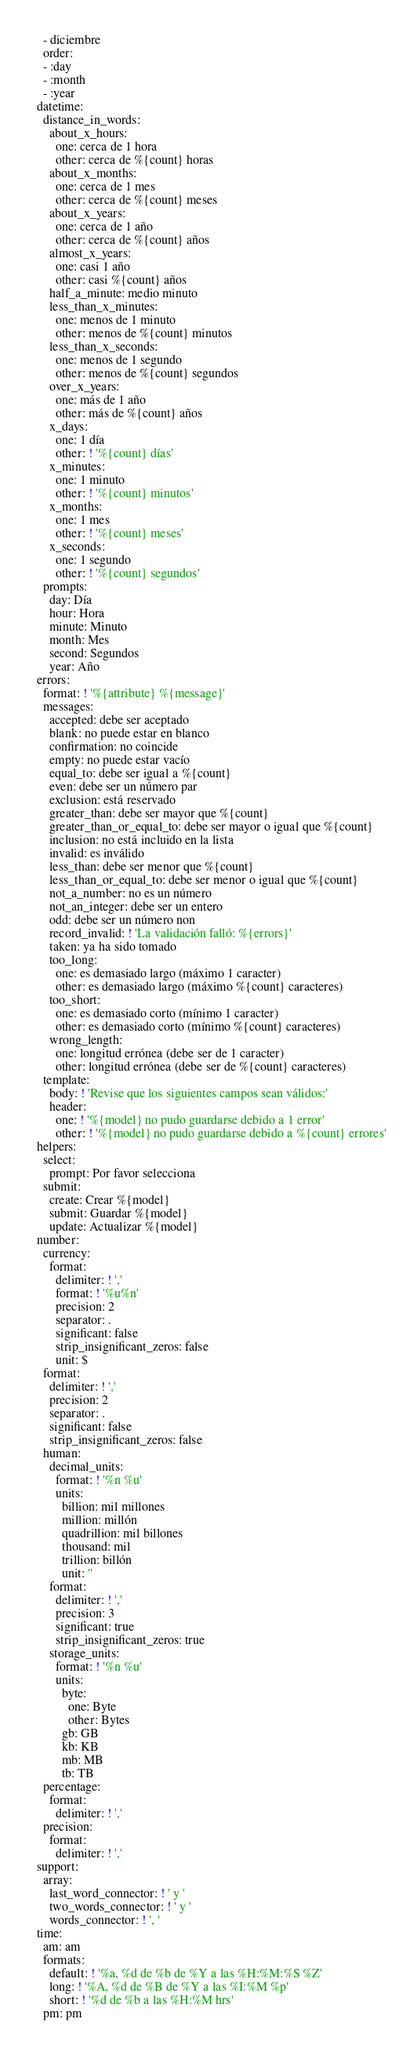<code> <loc_0><loc_0><loc_500><loc_500><_YAML_>    - diciembre
    order:
    - :day
    - :month
    - :year
  datetime:
    distance_in_words:
      about_x_hours:
        one: cerca de 1 hora
        other: cerca de %{count} horas
      about_x_months:
        one: cerca de 1 mes
        other: cerca de %{count} meses
      about_x_years:
        one: cerca de 1 año
        other: cerca de %{count} años
      almost_x_years:
        one: casi 1 año
        other: casi %{count} años
      half_a_minute: medio minuto
      less_than_x_minutes:
        one: menos de 1 minuto
        other: menos de %{count} minutos
      less_than_x_seconds:
        one: menos de 1 segundo
        other: menos de %{count} segundos
      over_x_years:
        one: más de 1 año
        other: más de %{count} años
      x_days:
        one: 1 día
        other: ! '%{count} días'
      x_minutes:
        one: 1 minuto
        other: ! '%{count} minutos'
      x_months:
        one: 1 mes
        other: ! '%{count} meses'
      x_seconds:
        one: 1 segundo
        other: ! '%{count} segundos'
    prompts:
      day: Día
      hour: Hora
      minute: Minuto
      month: Mes
      second: Segundos
      year: Año
  errors:
    format: ! '%{attribute} %{message}'
    messages:
      accepted: debe ser aceptado
      blank: no puede estar en blanco
      confirmation: no coincide
      empty: no puede estar vacío
      equal_to: debe ser igual a %{count}
      even: debe ser un número par
      exclusion: está reservado
      greater_than: debe ser mayor que %{count}
      greater_than_or_equal_to: debe ser mayor o igual que %{count}
      inclusion: no está incluido en la lista
      invalid: es inválido
      less_than: debe ser menor que %{count}
      less_than_or_equal_to: debe ser menor o igual que %{count}
      not_a_number: no es un número
      not_an_integer: debe ser un entero
      odd: debe ser un número non
      record_invalid: ! 'La validación falló: %{errors}'
      taken: ya ha sido tomado
      too_long:
        one: es demasiado largo (máximo 1 caracter)
        other: es demasiado largo (máximo %{count} caracteres)
      too_short:
        one: es demasiado corto (mínimo 1 caracter)
        other: es demasiado corto (mínimo %{count} caracteres)
      wrong_length:
        one: longitud errónea (debe ser de 1 caracter)
        other: longitud errónea (debe ser de %{count} caracteres)
    template:
      body: ! 'Revise que los siguientes campos sean válidos:'
      header:
        one: ! '%{model} no pudo guardarse debido a 1 error'
        other: ! '%{model} no pudo guardarse debido a %{count} errores'
  helpers:
    select:
      prompt: Por favor selecciona
    submit:
      create: Crear %{model}
      submit: Guardar %{model}
      update: Actualizar %{model}
  number:
    currency:
      format:
        delimiter: ! ','
        format: ! '%u%n'
        precision: 2
        separator: .
        significant: false
        strip_insignificant_zeros: false
        unit: $
    format:
      delimiter: ! ','
      precision: 2
      separator: .
      significant: false
      strip_insignificant_zeros: false
    human:
      decimal_units:
        format: ! '%n %u'
        units:
          billion: mil millones
          million: millón
          quadrillion: mil billones
          thousand: mil
          trillion: billón
          unit: ''
      format:
        delimiter: ! ','
        precision: 3
        significant: true
        strip_insignificant_zeros: true
      storage_units:
        format: ! '%n %u'
        units:
          byte:
            one: Byte
            other: Bytes
          gb: GB
          kb: KB
          mb: MB
          tb: TB
    percentage:
      format:
        delimiter: ! ','
    precision:
      format:
        delimiter: ! ','
  support:
    array:
      last_word_connector: ! ' y '
      two_words_connector: ! ' y '
      words_connector: ! ', '
  time:
    am: am
    formats:
      default: ! '%a, %d de %b de %Y a las %H:%M:%S %Z'
      long: ! '%A, %d de %B de %Y a las %I:%M %p'
      short: ! '%d de %b a las %H:%M hrs'
    pm: pm
</code> 